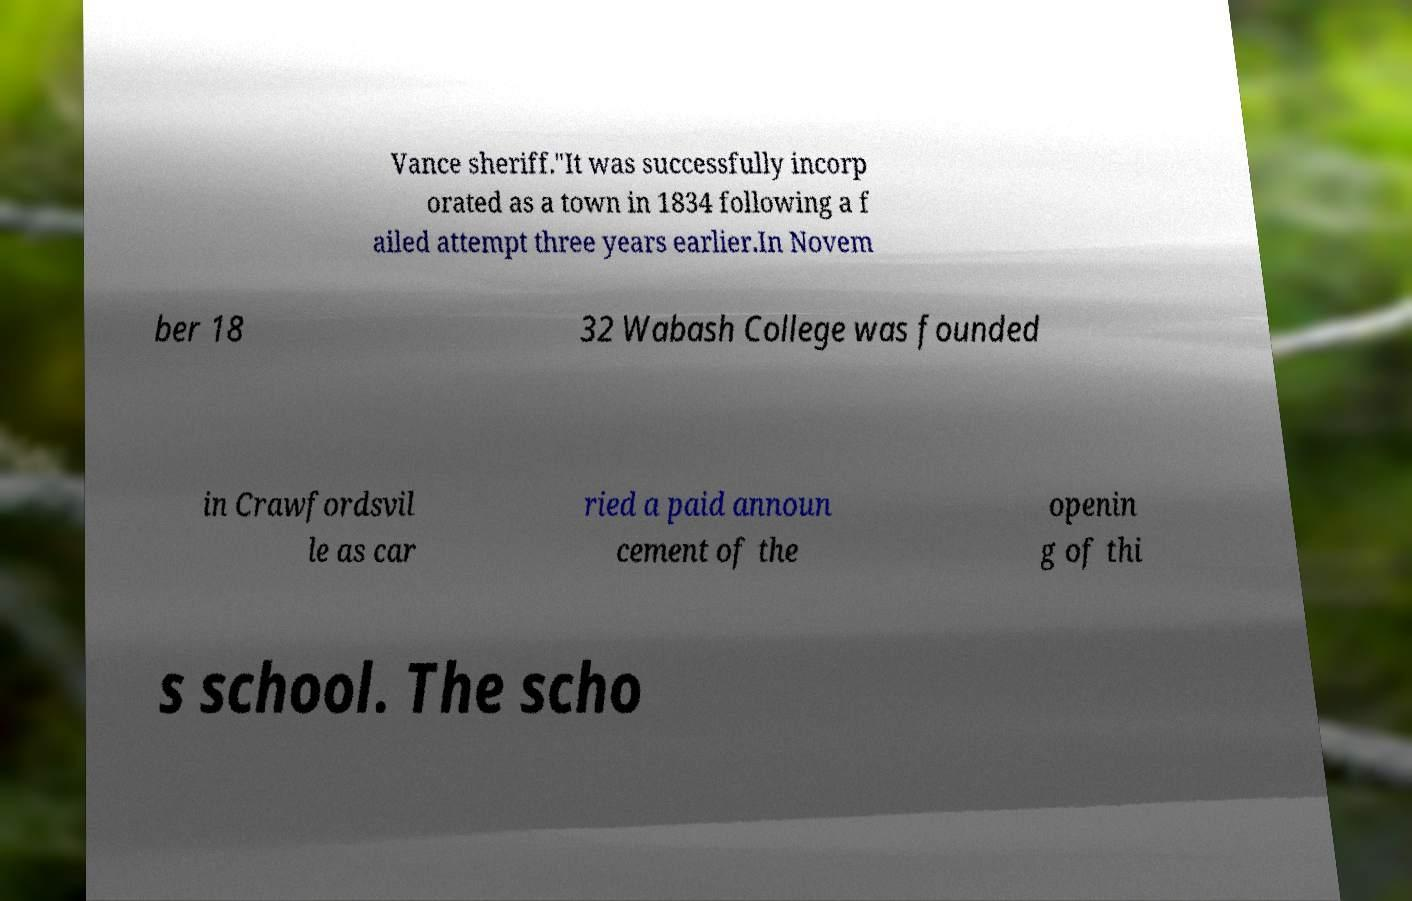Could you extract and type out the text from this image? Vance sheriff."It was successfully incorp orated as a town in 1834 following a f ailed attempt three years earlier.In Novem ber 18 32 Wabash College was founded in Crawfordsvil le as car ried a paid announ cement of the openin g of thi s school. The scho 